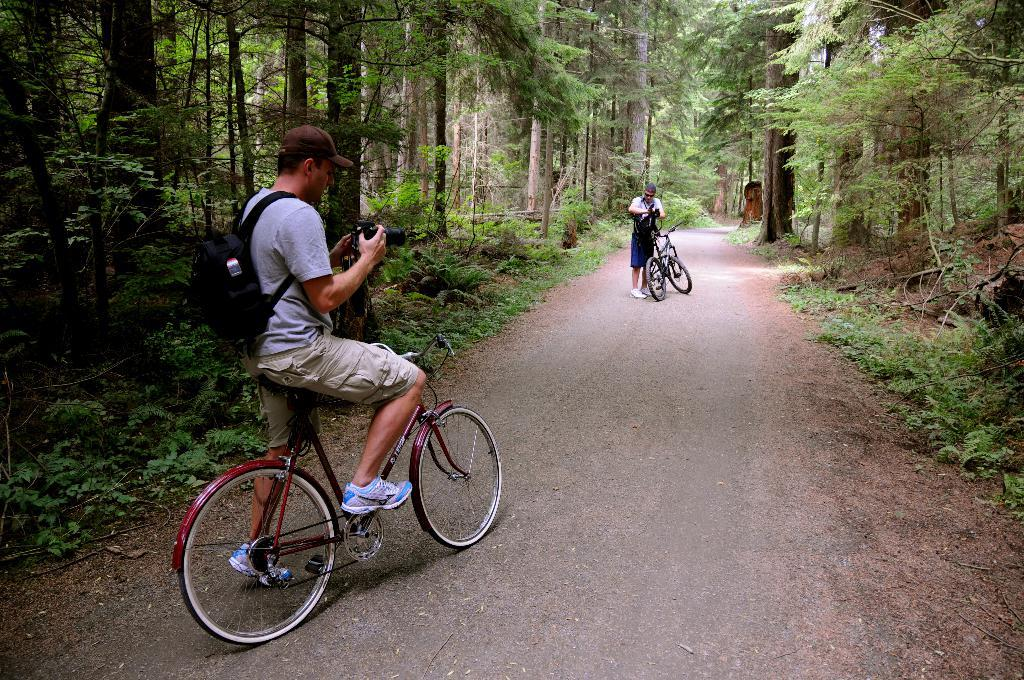What is located on either side of the road in the image? There are trees on either side of the road in the image. What is the man in the image doing? The man is riding a bicycle. What is the man holding while riding the bicycle? The man is holding a camera in his hands. Can you describe the road in the image? This is the road that the man is riding his bicycle on. What type of button can be seen on the man's shirt in the image? There is no button visible on the man's shirt in the image. Is there any sleet visible on the road in the image? There is no sleet visible on the road in the image. Can you describe the truck that is parked on the side of the road in the image? There is no truck present in the image. 